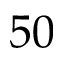<formula> <loc_0><loc_0><loc_500><loc_500>5 0</formula> 